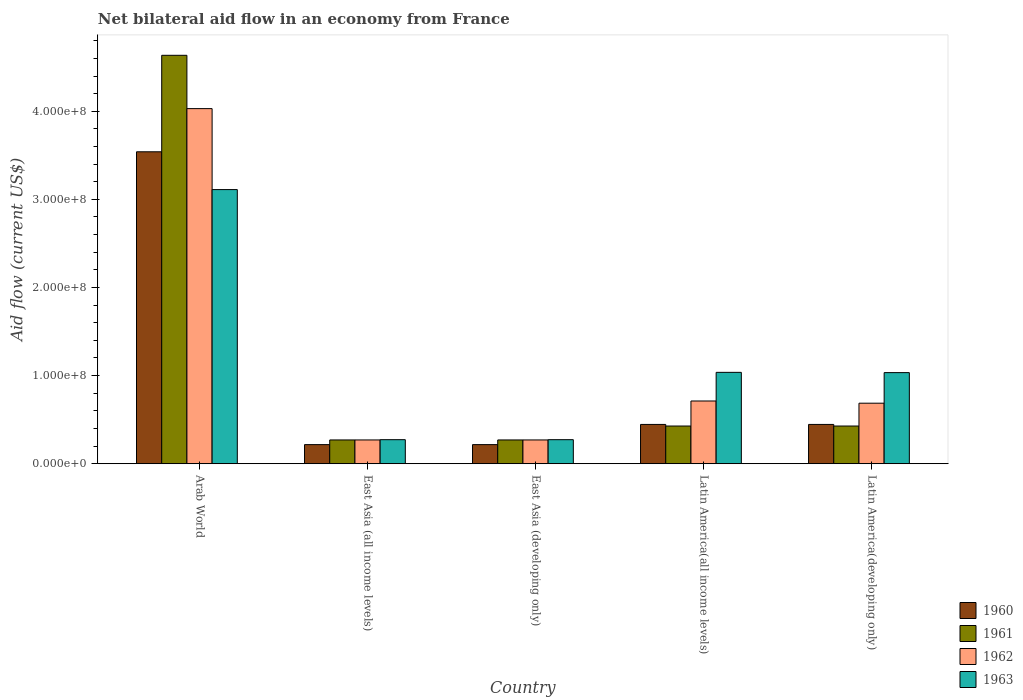How many different coloured bars are there?
Give a very brief answer. 4. How many groups of bars are there?
Your answer should be very brief. 5. How many bars are there on the 1st tick from the right?
Your answer should be compact. 4. What is the label of the 4th group of bars from the left?
Give a very brief answer. Latin America(all income levels). In how many cases, is the number of bars for a given country not equal to the number of legend labels?
Keep it short and to the point. 0. What is the net bilateral aid flow in 1960 in Latin America(all income levels)?
Your response must be concise. 4.46e+07. Across all countries, what is the maximum net bilateral aid flow in 1963?
Your answer should be compact. 3.11e+08. Across all countries, what is the minimum net bilateral aid flow in 1960?
Provide a short and direct response. 2.17e+07. In which country was the net bilateral aid flow in 1960 maximum?
Your answer should be compact. Arab World. In which country was the net bilateral aid flow in 1963 minimum?
Your answer should be compact. East Asia (all income levels). What is the total net bilateral aid flow in 1961 in the graph?
Offer a very short reply. 6.03e+08. What is the difference between the net bilateral aid flow in 1962 in Arab World and that in Latin America(developing only)?
Give a very brief answer. 3.34e+08. What is the difference between the net bilateral aid flow in 1961 in Latin America(all income levels) and the net bilateral aid flow in 1960 in East Asia (all income levels)?
Your answer should be very brief. 2.11e+07. What is the average net bilateral aid flow in 1962 per country?
Your response must be concise. 1.19e+08. What is the difference between the net bilateral aid flow of/in 1962 and net bilateral aid flow of/in 1963 in Latin America(developing only)?
Your answer should be very brief. -3.47e+07. In how many countries, is the net bilateral aid flow in 1961 greater than 300000000 US$?
Give a very brief answer. 1. What is the ratio of the net bilateral aid flow in 1962 in East Asia (developing only) to that in Latin America(developing only)?
Ensure brevity in your answer.  0.39. Is the net bilateral aid flow in 1963 in Arab World less than that in Latin America(developing only)?
Provide a short and direct response. No. Is the difference between the net bilateral aid flow in 1962 in East Asia (all income levels) and East Asia (developing only) greater than the difference between the net bilateral aid flow in 1963 in East Asia (all income levels) and East Asia (developing only)?
Provide a succinct answer. No. What is the difference between the highest and the second highest net bilateral aid flow in 1960?
Keep it short and to the point. 3.09e+08. What is the difference between the highest and the lowest net bilateral aid flow in 1960?
Keep it short and to the point. 3.32e+08. In how many countries, is the net bilateral aid flow in 1963 greater than the average net bilateral aid flow in 1963 taken over all countries?
Make the answer very short. 1. Is the sum of the net bilateral aid flow in 1962 in East Asia (developing only) and Latin America(all income levels) greater than the maximum net bilateral aid flow in 1963 across all countries?
Your answer should be compact. No. Is it the case that in every country, the sum of the net bilateral aid flow in 1963 and net bilateral aid flow in 1961 is greater than the net bilateral aid flow in 1962?
Offer a very short reply. Yes. Are all the bars in the graph horizontal?
Offer a very short reply. No. How many countries are there in the graph?
Make the answer very short. 5. Are the values on the major ticks of Y-axis written in scientific E-notation?
Provide a short and direct response. Yes. Does the graph contain grids?
Make the answer very short. No. Where does the legend appear in the graph?
Provide a succinct answer. Bottom right. What is the title of the graph?
Offer a very short reply. Net bilateral aid flow in an economy from France. Does "1960" appear as one of the legend labels in the graph?
Provide a succinct answer. Yes. What is the label or title of the X-axis?
Give a very brief answer. Country. What is the label or title of the Y-axis?
Your answer should be very brief. Aid flow (current US$). What is the Aid flow (current US$) of 1960 in Arab World?
Make the answer very short. 3.54e+08. What is the Aid flow (current US$) in 1961 in Arab World?
Your answer should be compact. 4.64e+08. What is the Aid flow (current US$) in 1962 in Arab World?
Provide a succinct answer. 4.03e+08. What is the Aid flow (current US$) of 1963 in Arab World?
Your answer should be compact. 3.11e+08. What is the Aid flow (current US$) of 1960 in East Asia (all income levels)?
Make the answer very short. 2.17e+07. What is the Aid flow (current US$) in 1961 in East Asia (all income levels)?
Make the answer very short. 2.70e+07. What is the Aid flow (current US$) in 1962 in East Asia (all income levels)?
Provide a succinct answer. 2.70e+07. What is the Aid flow (current US$) in 1963 in East Asia (all income levels)?
Your response must be concise. 2.73e+07. What is the Aid flow (current US$) of 1960 in East Asia (developing only)?
Give a very brief answer. 2.17e+07. What is the Aid flow (current US$) in 1961 in East Asia (developing only)?
Keep it short and to the point. 2.70e+07. What is the Aid flow (current US$) of 1962 in East Asia (developing only)?
Your response must be concise. 2.70e+07. What is the Aid flow (current US$) in 1963 in East Asia (developing only)?
Your response must be concise. 2.73e+07. What is the Aid flow (current US$) in 1960 in Latin America(all income levels)?
Provide a short and direct response. 4.46e+07. What is the Aid flow (current US$) of 1961 in Latin America(all income levels)?
Make the answer very short. 4.28e+07. What is the Aid flow (current US$) in 1962 in Latin America(all income levels)?
Ensure brevity in your answer.  7.12e+07. What is the Aid flow (current US$) of 1963 in Latin America(all income levels)?
Your answer should be compact. 1.04e+08. What is the Aid flow (current US$) in 1960 in Latin America(developing only)?
Your answer should be very brief. 4.46e+07. What is the Aid flow (current US$) of 1961 in Latin America(developing only)?
Offer a terse response. 4.28e+07. What is the Aid flow (current US$) in 1962 in Latin America(developing only)?
Provide a short and direct response. 6.87e+07. What is the Aid flow (current US$) of 1963 in Latin America(developing only)?
Ensure brevity in your answer.  1.03e+08. Across all countries, what is the maximum Aid flow (current US$) of 1960?
Offer a terse response. 3.54e+08. Across all countries, what is the maximum Aid flow (current US$) in 1961?
Offer a terse response. 4.64e+08. Across all countries, what is the maximum Aid flow (current US$) in 1962?
Provide a succinct answer. 4.03e+08. Across all countries, what is the maximum Aid flow (current US$) of 1963?
Your answer should be compact. 3.11e+08. Across all countries, what is the minimum Aid flow (current US$) of 1960?
Your answer should be very brief. 2.17e+07. Across all countries, what is the minimum Aid flow (current US$) in 1961?
Give a very brief answer. 2.70e+07. Across all countries, what is the minimum Aid flow (current US$) of 1962?
Your answer should be very brief. 2.70e+07. Across all countries, what is the minimum Aid flow (current US$) of 1963?
Keep it short and to the point. 2.73e+07. What is the total Aid flow (current US$) in 1960 in the graph?
Your answer should be compact. 4.87e+08. What is the total Aid flow (current US$) in 1961 in the graph?
Provide a succinct answer. 6.03e+08. What is the total Aid flow (current US$) of 1962 in the graph?
Offer a very short reply. 5.97e+08. What is the total Aid flow (current US$) in 1963 in the graph?
Your answer should be compact. 5.73e+08. What is the difference between the Aid flow (current US$) of 1960 in Arab World and that in East Asia (all income levels)?
Keep it short and to the point. 3.32e+08. What is the difference between the Aid flow (current US$) in 1961 in Arab World and that in East Asia (all income levels)?
Provide a succinct answer. 4.36e+08. What is the difference between the Aid flow (current US$) of 1962 in Arab World and that in East Asia (all income levels)?
Your answer should be very brief. 3.76e+08. What is the difference between the Aid flow (current US$) of 1963 in Arab World and that in East Asia (all income levels)?
Ensure brevity in your answer.  2.84e+08. What is the difference between the Aid flow (current US$) of 1960 in Arab World and that in East Asia (developing only)?
Give a very brief answer. 3.32e+08. What is the difference between the Aid flow (current US$) of 1961 in Arab World and that in East Asia (developing only)?
Your response must be concise. 4.36e+08. What is the difference between the Aid flow (current US$) of 1962 in Arab World and that in East Asia (developing only)?
Your answer should be compact. 3.76e+08. What is the difference between the Aid flow (current US$) in 1963 in Arab World and that in East Asia (developing only)?
Provide a short and direct response. 2.84e+08. What is the difference between the Aid flow (current US$) in 1960 in Arab World and that in Latin America(all income levels)?
Your answer should be very brief. 3.09e+08. What is the difference between the Aid flow (current US$) in 1961 in Arab World and that in Latin America(all income levels)?
Offer a very short reply. 4.21e+08. What is the difference between the Aid flow (current US$) in 1962 in Arab World and that in Latin America(all income levels)?
Your response must be concise. 3.32e+08. What is the difference between the Aid flow (current US$) of 1963 in Arab World and that in Latin America(all income levels)?
Provide a short and direct response. 2.07e+08. What is the difference between the Aid flow (current US$) in 1960 in Arab World and that in Latin America(developing only)?
Provide a succinct answer. 3.09e+08. What is the difference between the Aid flow (current US$) in 1961 in Arab World and that in Latin America(developing only)?
Your response must be concise. 4.21e+08. What is the difference between the Aid flow (current US$) of 1962 in Arab World and that in Latin America(developing only)?
Keep it short and to the point. 3.34e+08. What is the difference between the Aid flow (current US$) in 1963 in Arab World and that in Latin America(developing only)?
Your response must be concise. 2.08e+08. What is the difference between the Aid flow (current US$) of 1961 in East Asia (all income levels) and that in East Asia (developing only)?
Provide a short and direct response. 0. What is the difference between the Aid flow (current US$) of 1963 in East Asia (all income levels) and that in East Asia (developing only)?
Your response must be concise. 0. What is the difference between the Aid flow (current US$) in 1960 in East Asia (all income levels) and that in Latin America(all income levels)?
Ensure brevity in your answer.  -2.29e+07. What is the difference between the Aid flow (current US$) in 1961 in East Asia (all income levels) and that in Latin America(all income levels)?
Provide a succinct answer. -1.58e+07. What is the difference between the Aid flow (current US$) in 1962 in East Asia (all income levels) and that in Latin America(all income levels)?
Ensure brevity in your answer.  -4.42e+07. What is the difference between the Aid flow (current US$) in 1963 in East Asia (all income levels) and that in Latin America(all income levels)?
Offer a terse response. -7.64e+07. What is the difference between the Aid flow (current US$) in 1960 in East Asia (all income levels) and that in Latin America(developing only)?
Make the answer very short. -2.29e+07. What is the difference between the Aid flow (current US$) of 1961 in East Asia (all income levels) and that in Latin America(developing only)?
Ensure brevity in your answer.  -1.58e+07. What is the difference between the Aid flow (current US$) in 1962 in East Asia (all income levels) and that in Latin America(developing only)?
Offer a terse response. -4.17e+07. What is the difference between the Aid flow (current US$) in 1963 in East Asia (all income levels) and that in Latin America(developing only)?
Offer a very short reply. -7.61e+07. What is the difference between the Aid flow (current US$) of 1960 in East Asia (developing only) and that in Latin America(all income levels)?
Keep it short and to the point. -2.29e+07. What is the difference between the Aid flow (current US$) in 1961 in East Asia (developing only) and that in Latin America(all income levels)?
Your answer should be compact. -1.58e+07. What is the difference between the Aid flow (current US$) of 1962 in East Asia (developing only) and that in Latin America(all income levels)?
Make the answer very short. -4.42e+07. What is the difference between the Aid flow (current US$) of 1963 in East Asia (developing only) and that in Latin America(all income levels)?
Ensure brevity in your answer.  -7.64e+07. What is the difference between the Aid flow (current US$) in 1960 in East Asia (developing only) and that in Latin America(developing only)?
Ensure brevity in your answer.  -2.29e+07. What is the difference between the Aid flow (current US$) of 1961 in East Asia (developing only) and that in Latin America(developing only)?
Your answer should be compact. -1.58e+07. What is the difference between the Aid flow (current US$) in 1962 in East Asia (developing only) and that in Latin America(developing only)?
Offer a very short reply. -4.17e+07. What is the difference between the Aid flow (current US$) of 1963 in East Asia (developing only) and that in Latin America(developing only)?
Offer a terse response. -7.61e+07. What is the difference between the Aid flow (current US$) of 1960 in Latin America(all income levels) and that in Latin America(developing only)?
Keep it short and to the point. 0. What is the difference between the Aid flow (current US$) of 1962 in Latin America(all income levels) and that in Latin America(developing only)?
Your answer should be compact. 2.50e+06. What is the difference between the Aid flow (current US$) in 1960 in Arab World and the Aid flow (current US$) in 1961 in East Asia (all income levels)?
Offer a very short reply. 3.27e+08. What is the difference between the Aid flow (current US$) in 1960 in Arab World and the Aid flow (current US$) in 1962 in East Asia (all income levels)?
Give a very brief answer. 3.27e+08. What is the difference between the Aid flow (current US$) of 1960 in Arab World and the Aid flow (current US$) of 1963 in East Asia (all income levels)?
Your answer should be very brief. 3.27e+08. What is the difference between the Aid flow (current US$) of 1961 in Arab World and the Aid flow (current US$) of 1962 in East Asia (all income levels)?
Your answer should be very brief. 4.36e+08. What is the difference between the Aid flow (current US$) of 1961 in Arab World and the Aid flow (current US$) of 1963 in East Asia (all income levels)?
Offer a very short reply. 4.36e+08. What is the difference between the Aid flow (current US$) of 1962 in Arab World and the Aid flow (current US$) of 1963 in East Asia (all income levels)?
Your response must be concise. 3.76e+08. What is the difference between the Aid flow (current US$) in 1960 in Arab World and the Aid flow (current US$) in 1961 in East Asia (developing only)?
Make the answer very short. 3.27e+08. What is the difference between the Aid flow (current US$) of 1960 in Arab World and the Aid flow (current US$) of 1962 in East Asia (developing only)?
Offer a terse response. 3.27e+08. What is the difference between the Aid flow (current US$) in 1960 in Arab World and the Aid flow (current US$) in 1963 in East Asia (developing only)?
Your answer should be compact. 3.27e+08. What is the difference between the Aid flow (current US$) in 1961 in Arab World and the Aid flow (current US$) in 1962 in East Asia (developing only)?
Offer a very short reply. 4.36e+08. What is the difference between the Aid flow (current US$) in 1961 in Arab World and the Aid flow (current US$) in 1963 in East Asia (developing only)?
Offer a very short reply. 4.36e+08. What is the difference between the Aid flow (current US$) of 1962 in Arab World and the Aid flow (current US$) of 1963 in East Asia (developing only)?
Offer a very short reply. 3.76e+08. What is the difference between the Aid flow (current US$) in 1960 in Arab World and the Aid flow (current US$) in 1961 in Latin America(all income levels)?
Ensure brevity in your answer.  3.11e+08. What is the difference between the Aid flow (current US$) of 1960 in Arab World and the Aid flow (current US$) of 1962 in Latin America(all income levels)?
Make the answer very short. 2.83e+08. What is the difference between the Aid flow (current US$) in 1960 in Arab World and the Aid flow (current US$) in 1963 in Latin America(all income levels)?
Your answer should be very brief. 2.50e+08. What is the difference between the Aid flow (current US$) of 1961 in Arab World and the Aid flow (current US$) of 1962 in Latin America(all income levels)?
Your response must be concise. 3.92e+08. What is the difference between the Aid flow (current US$) in 1961 in Arab World and the Aid flow (current US$) in 1963 in Latin America(all income levels)?
Make the answer very short. 3.60e+08. What is the difference between the Aid flow (current US$) in 1962 in Arab World and the Aid flow (current US$) in 1963 in Latin America(all income levels)?
Ensure brevity in your answer.  2.99e+08. What is the difference between the Aid flow (current US$) of 1960 in Arab World and the Aid flow (current US$) of 1961 in Latin America(developing only)?
Give a very brief answer. 3.11e+08. What is the difference between the Aid flow (current US$) of 1960 in Arab World and the Aid flow (current US$) of 1962 in Latin America(developing only)?
Provide a short and direct response. 2.85e+08. What is the difference between the Aid flow (current US$) in 1960 in Arab World and the Aid flow (current US$) in 1963 in Latin America(developing only)?
Your answer should be very brief. 2.51e+08. What is the difference between the Aid flow (current US$) of 1961 in Arab World and the Aid flow (current US$) of 1962 in Latin America(developing only)?
Make the answer very short. 3.95e+08. What is the difference between the Aid flow (current US$) of 1961 in Arab World and the Aid flow (current US$) of 1963 in Latin America(developing only)?
Provide a succinct answer. 3.60e+08. What is the difference between the Aid flow (current US$) in 1962 in Arab World and the Aid flow (current US$) in 1963 in Latin America(developing only)?
Offer a terse response. 3.00e+08. What is the difference between the Aid flow (current US$) of 1960 in East Asia (all income levels) and the Aid flow (current US$) of 1961 in East Asia (developing only)?
Provide a succinct answer. -5.30e+06. What is the difference between the Aid flow (current US$) in 1960 in East Asia (all income levels) and the Aid flow (current US$) in 1962 in East Asia (developing only)?
Offer a very short reply. -5.30e+06. What is the difference between the Aid flow (current US$) of 1960 in East Asia (all income levels) and the Aid flow (current US$) of 1963 in East Asia (developing only)?
Keep it short and to the point. -5.60e+06. What is the difference between the Aid flow (current US$) of 1960 in East Asia (all income levels) and the Aid flow (current US$) of 1961 in Latin America(all income levels)?
Keep it short and to the point. -2.11e+07. What is the difference between the Aid flow (current US$) in 1960 in East Asia (all income levels) and the Aid flow (current US$) in 1962 in Latin America(all income levels)?
Provide a succinct answer. -4.95e+07. What is the difference between the Aid flow (current US$) of 1960 in East Asia (all income levels) and the Aid flow (current US$) of 1963 in Latin America(all income levels)?
Offer a terse response. -8.20e+07. What is the difference between the Aid flow (current US$) in 1961 in East Asia (all income levels) and the Aid flow (current US$) in 1962 in Latin America(all income levels)?
Give a very brief answer. -4.42e+07. What is the difference between the Aid flow (current US$) of 1961 in East Asia (all income levels) and the Aid flow (current US$) of 1963 in Latin America(all income levels)?
Give a very brief answer. -7.67e+07. What is the difference between the Aid flow (current US$) in 1962 in East Asia (all income levels) and the Aid flow (current US$) in 1963 in Latin America(all income levels)?
Keep it short and to the point. -7.67e+07. What is the difference between the Aid flow (current US$) in 1960 in East Asia (all income levels) and the Aid flow (current US$) in 1961 in Latin America(developing only)?
Your answer should be compact. -2.11e+07. What is the difference between the Aid flow (current US$) in 1960 in East Asia (all income levels) and the Aid flow (current US$) in 1962 in Latin America(developing only)?
Provide a short and direct response. -4.70e+07. What is the difference between the Aid flow (current US$) in 1960 in East Asia (all income levels) and the Aid flow (current US$) in 1963 in Latin America(developing only)?
Offer a very short reply. -8.17e+07. What is the difference between the Aid flow (current US$) of 1961 in East Asia (all income levels) and the Aid flow (current US$) of 1962 in Latin America(developing only)?
Your response must be concise. -4.17e+07. What is the difference between the Aid flow (current US$) of 1961 in East Asia (all income levels) and the Aid flow (current US$) of 1963 in Latin America(developing only)?
Your answer should be very brief. -7.64e+07. What is the difference between the Aid flow (current US$) in 1962 in East Asia (all income levels) and the Aid flow (current US$) in 1963 in Latin America(developing only)?
Provide a short and direct response. -7.64e+07. What is the difference between the Aid flow (current US$) in 1960 in East Asia (developing only) and the Aid flow (current US$) in 1961 in Latin America(all income levels)?
Give a very brief answer. -2.11e+07. What is the difference between the Aid flow (current US$) in 1960 in East Asia (developing only) and the Aid flow (current US$) in 1962 in Latin America(all income levels)?
Give a very brief answer. -4.95e+07. What is the difference between the Aid flow (current US$) in 1960 in East Asia (developing only) and the Aid flow (current US$) in 1963 in Latin America(all income levels)?
Give a very brief answer. -8.20e+07. What is the difference between the Aid flow (current US$) of 1961 in East Asia (developing only) and the Aid flow (current US$) of 1962 in Latin America(all income levels)?
Your response must be concise. -4.42e+07. What is the difference between the Aid flow (current US$) of 1961 in East Asia (developing only) and the Aid flow (current US$) of 1963 in Latin America(all income levels)?
Ensure brevity in your answer.  -7.67e+07. What is the difference between the Aid flow (current US$) in 1962 in East Asia (developing only) and the Aid flow (current US$) in 1963 in Latin America(all income levels)?
Provide a succinct answer. -7.67e+07. What is the difference between the Aid flow (current US$) in 1960 in East Asia (developing only) and the Aid flow (current US$) in 1961 in Latin America(developing only)?
Your answer should be very brief. -2.11e+07. What is the difference between the Aid flow (current US$) in 1960 in East Asia (developing only) and the Aid flow (current US$) in 1962 in Latin America(developing only)?
Ensure brevity in your answer.  -4.70e+07. What is the difference between the Aid flow (current US$) in 1960 in East Asia (developing only) and the Aid flow (current US$) in 1963 in Latin America(developing only)?
Provide a succinct answer. -8.17e+07. What is the difference between the Aid flow (current US$) of 1961 in East Asia (developing only) and the Aid flow (current US$) of 1962 in Latin America(developing only)?
Ensure brevity in your answer.  -4.17e+07. What is the difference between the Aid flow (current US$) in 1961 in East Asia (developing only) and the Aid flow (current US$) in 1963 in Latin America(developing only)?
Keep it short and to the point. -7.64e+07. What is the difference between the Aid flow (current US$) of 1962 in East Asia (developing only) and the Aid flow (current US$) of 1963 in Latin America(developing only)?
Your response must be concise. -7.64e+07. What is the difference between the Aid flow (current US$) in 1960 in Latin America(all income levels) and the Aid flow (current US$) in 1961 in Latin America(developing only)?
Keep it short and to the point. 1.80e+06. What is the difference between the Aid flow (current US$) in 1960 in Latin America(all income levels) and the Aid flow (current US$) in 1962 in Latin America(developing only)?
Your response must be concise. -2.41e+07. What is the difference between the Aid flow (current US$) in 1960 in Latin America(all income levels) and the Aid flow (current US$) in 1963 in Latin America(developing only)?
Offer a very short reply. -5.88e+07. What is the difference between the Aid flow (current US$) in 1961 in Latin America(all income levels) and the Aid flow (current US$) in 1962 in Latin America(developing only)?
Ensure brevity in your answer.  -2.59e+07. What is the difference between the Aid flow (current US$) in 1961 in Latin America(all income levels) and the Aid flow (current US$) in 1963 in Latin America(developing only)?
Make the answer very short. -6.06e+07. What is the difference between the Aid flow (current US$) in 1962 in Latin America(all income levels) and the Aid flow (current US$) in 1963 in Latin America(developing only)?
Your answer should be compact. -3.22e+07. What is the average Aid flow (current US$) of 1960 per country?
Provide a succinct answer. 9.73e+07. What is the average Aid flow (current US$) in 1961 per country?
Provide a short and direct response. 1.21e+08. What is the average Aid flow (current US$) in 1962 per country?
Your response must be concise. 1.19e+08. What is the average Aid flow (current US$) in 1963 per country?
Offer a terse response. 1.15e+08. What is the difference between the Aid flow (current US$) in 1960 and Aid flow (current US$) in 1961 in Arab World?
Your answer should be very brief. -1.10e+08. What is the difference between the Aid flow (current US$) of 1960 and Aid flow (current US$) of 1962 in Arab World?
Provide a short and direct response. -4.90e+07. What is the difference between the Aid flow (current US$) in 1960 and Aid flow (current US$) in 1963 in Arab World?
Ensure brevity in your answer.  4.29e+07. What is the difference between the Aid flow (current US$) of 1961 and Aid flow (current US$) of 1962 in Arab World?
Ensure brevity in your answer.  6.05e+07. What is the difference between the Aid flow (current US$) in 1961 and Aid flow (current US$) in 1963 in Arab World?
Keep it short and to the point. 1.52e+08. What is the difference between the Aid flow (current US$) of 1962 and Aid flow (current US$) of 1963 in Arab World?
Your answer should be compact. 9.19e+07. What is the difference between the Aid flow (current US$) of 1960 and Aid flow (current US$) of 1961 in East Asia (all income levels)?
Give a very brief answer. -5.30e+06. What is the difference between the Aid flow (current US$) of 1960 and Aid flow (current US$) of 1962 in East Asia (all income levels)?
Provide a short and direct response. -5.30e+06. What is the difference between the Aid flow (current US$) of 1960 and Aid flow (current US$) of 1963 in East Asia (all income levels)?
Your answer should be very brief. -5.60e+06. What is the difference between the Aid flow (current US$) of 1961 and Aid flow (current US$) of 1962 in East Asia (all income levels)?
Ensure brevity in your answer.  0. What is the difference between the Aid flow (current US$) in 1960 and Aid flow (current US$) in 1961 in East Asia (developing only)?
Provide a short and direct response. -5.30e+06. What is the difference between the Aid flow (current US$) in 1960 and Aid flow (current US$) in 1962 in East Asia (developing only)?
Your answer should be compact. -5.30e+06. What is the difference between the Aid flow (current US$) of 1960 and Aid flow (current US$) of 1963 in East Asia (developing only)?
Provide a short and direct response. -5.60e+06. What is the difference between the Aid flow (current US$) of 1961 and Aid flow (current US$) of 1962 in East Asia (developing only)?
Provide a short and direct response. 0. What is the difference between the Aid flow (current US$) of 1960 and Aid flow (current US$) of 1961 in Latin America(all income levels)?
Ensure brevity in your answer.  1.80e+06. What is the difference between the Aid flow (current US$) in 1960 and Aid flow (current US$) in 1962 in Latin America(all income levels)?
Ensure brevity in your answer.  -2.66e+07. What is the difference between the Aid flow (current US$) in 1960 and Aid flow (current US$) in 1963 in Latin America(all income levels)?
Make the answer very short. -5.91e+07. What is the difference between the Aid flow (current US$) in 1961 and Aid flow (current US$) in 1962 in Latin America(all income levels)?
Keep it short and to the point. -2.84e+07. What is the difference between the Aid flow (current US$) in 1961 and Aid flow (current US$) in 1963 in Latin America(all income levels)?
Offer a very short reply. -6.09e+07. What is the difference between the Aid flow (current US$) in 1962 and Aid flow (current US$) in 1963 in Latin America(all income levels)?
Provide a short and direct response. -3.25e+07. What is the difference between the Aid flow (current US$) in 1960 and Aid flow (current US$) in 1961 in Latin America(developing only)?
Your answer should be compact. 1.80e+06. What is the difference between the Aid flow (current US$) of 1960 and Aid flow (current US$) of 1962 in Latin America(developing only)?
Offer a terse response. -2.41e+07. What is the difference between the Aid flow (current US$) of 1960 and Aid flow (current US$) of 1963 in Latin America(developing only)?
Your response must be concise. -5.88e+07. What is the difference between the Aid flow (current US$) in 1961 and Aid flow (current US$) in 1962 in Latin America(developing only)?
Offer a terse response. -2.59e+07. What is the difference between the Aid flow (current US$) of 1961 and Aid flow (current US$) of 1963 in Latin America(developing only)?
Offer a terse response. -6.06e+07. What is the difference between the Aid flow (current US$) of 1962 and Aid flow (current US$) of 1963 in Latin America(developing only)?
Provide a short and direct response. -3.47e+07. What is the ratio of the Aid flow (current US$) of 1960 in Arab World to that in East Asia (all income levels)?
Offer a terse response. 16.31. What is the ratio of the Aid flow (current US$) in 1961 in Arab World to that in East Asia (all income levels)?
Offer a very short reply. 17.17. What is the ratio of the Aid flow (current US$) in 1962 in Arab World to that in East Asia (all income levels)?
Offer a very short reply. 14.93. What is the ratio of the Aid flow (current US$) in 1963 in Arab World to that in East Asia (all income levels)?
Give a very brief answer. 11.4. What is the ratio of the Aid flow (current US$) in 1960 in Arab World to that in East Asia (developing only)?
Offer a very short reply. 16.31. What is the ratio of the Aid flow (current US$) of 1961 in Arab World to that in East Asia (developing only)?
Your response must be concise. 17.17. What is the ratio of the Aid flow (current US$) of 1962 in Arab World to that in East Asia (developing only)?
Ensure brevity in your answer.  14.93. What is the ratio of the Aid flow (current US$) of 1963 in Arab World to that in East Asia (developing only)?
Your response must be concise. 11.4. What is the ratio of the Aid flow (current US$) in 1960 in Arab World to that in Latin America(all income levels)?
Provide a succinct answer. 7.94. What is the ratio of the Aid flow (current US$) of 1961 in Arab World to that in Latin America(all income levels)?
Your response must be concise. 10.83. What is the ratio of the Aid flow (current US$) of 1962 in Arab World to that in Latin America(all income levels)?
Keep it short and to the point. 5.66. What is the ratio of the Aid flow (current US$) of 1963 in Arab World to that in Latin America(all income levels)?
Offer a very short reply. 3. What is the ratio of the Aid flow (current US$) in 1960 in Arab World to that in Latin America(developing only)?
Your response must be concise. 7.94. What is the ratio of the Aid flow (current US$) of 1961 in Arab World to that in Latin America(developing only)?
Ensure brevity in your answer.  10.83. What is the ratio of the Aid flow (current US$) in 1962 in Arab World to that in Latin America(developing only)?
Provide a short and direct response. 5.87. What is the ratio of the Aid flow (current US$) of 1963 in Arab World to that in Latin America(developing only)?
Your answer should be very brief. 3.01. What is the ratio of the Aid flow (current US$) of 1961 in East Asia (all income levels) to that in East Asia (developing only)?
Your answer should be compact. 1. What is the ratio of the Aid flow (current US$) of 1960 in East Asia (all income levels) to that in Latin America(all income levels)?
Your answer should be compact. 0.49. What is the ratio of the Aid flow (current US$) in 1961 in East Asia (all income levels) to that in Latin America(all income levels)?
Provide a short and direct response. 0.63. What is the ratio of the Aid flow (current US$) in 1962 in East Asia (all income levels) to that in Latin America(all income levels)?
Keep it short and to the point. 0.38. What is the ratio of the Aid flow (current US$) of 1963 in East Asia (all income levels) to that in Latin America(all income levels)?
Your answer should be compact. 0.26. What is the ratio of the Aid flow (current US$) in 1960 in East Asia (all income levels) to that in Latin America(developing only)?
Ensure brevity in your answer.  0.49. What is the ratio of the Aid flow (current US$) of 1961 in East Asia (all income levels) to that in Latin America(developing only)?
Give a very brief answer. 0.63. What is the ratio of the Aid flow (current US$) of 1962 in East Asia (all income levels) to that in Latin America(developing only)?
Your answer should be very brief. 0.39. What is the ratio of the Aid flow (current US$) in 1963 in East Asia (all income levels) to that in Latin America(developing only)?
Make the answer very short. 0.26. What is the ratio of the Aid flow (current US$) in 1960 in East Asia (developing only) to that in Latin America(all income levels)?
Offer a very short reply. 0.49. What is the ratio of the Aid flow (current US$) of 1961 in East Asia (developing only) to that in Latin America(all income levels)?
Your answer should be compact. 0.63. What is the ratio of the Aid flow (current US$) in 1962 in East Asia (developing only) to that in Latin America(all income levels)?
Your answer should be compact. 0.38. What is the ratio of the Aid flow (current US$) in 1963 in East Asia (developing only) to that in Latin America(all income levels)?
Give a very brief answer. 0.26. What is the ratio of the Aid flow (current US$) of 1960 in East Asia (developing only) to that in Latin America(developing only)?
Make the answer very short. 0.49. What is the ratio of the Aid flow (current US$) of 1961 in East Asia (developing only) to that in Latin America(developing only)?
Make the answer very short. 0.63. What is the ratio of the Aid flow (current US$) in 1962 in East Asia (developing only) to that in Latin America(developing only)?
Keep it short and to the point. 0.39. What is the ratio of the Aid flow (current US$) of 1963 in East Asia (developing only) to that in Latin America(developing only)?
Make the answer very short. 0.26. What is the ratio of the Aid flow (current US$) of 1960 in Latin America(all income levels) to that in Latin America(developing only)?
Ensure brevity in your answer.  1. What is the ratio of the Aid flow (current US$) of 1961 in Latin America(all income levels) to that in Latin America(developing only)?
Ensure brevity in your answer.  1. What is the ratio of the Aid flow (current US$) of 1962 in Latin America(all income levels) to that in Latin America(developing only)?
Provide a succinct answer. 1.04. What is the ratio of the Aid flow (current US$) in 1963 in Latin America(all income levels) to that in Latin America(developing only)?
Your answer should be very brief. 1. What is the difference between the highest and the second highest Aid flow (current US$) of 1960?
Make the answer very short. 3.09e+08. What is the difference between the highest and the second highest Aid flow (current US$) of 1961?
Give a very brief answer. 4.21e+08. What is the difference between the highest and the second highest Aid flow (current US$) in 1962?
Make the answer very short. 3.32e+08. What is the difference between the highest and the second highest Aid flow (current US$) in 1963?
Your response must be concise. 2.07e+08. What is the difference between the highest and the lowest Aid flow (current US$) in 1960?
Your response must be concise. 3.32e+08. What is the difference between the highest and the lowest Aid flow (current US$) in 1961?
Your response must be concise. 4.36e+08. What is the difference between the highest and the lowest Aid flow (current US$) of 1962?
Provide a succinct answer. 3.76e+08. What is the difference between the highest and the lowest Aid flow (current US$) in 1963?
Offer a very short reply. 2.84e+08. 